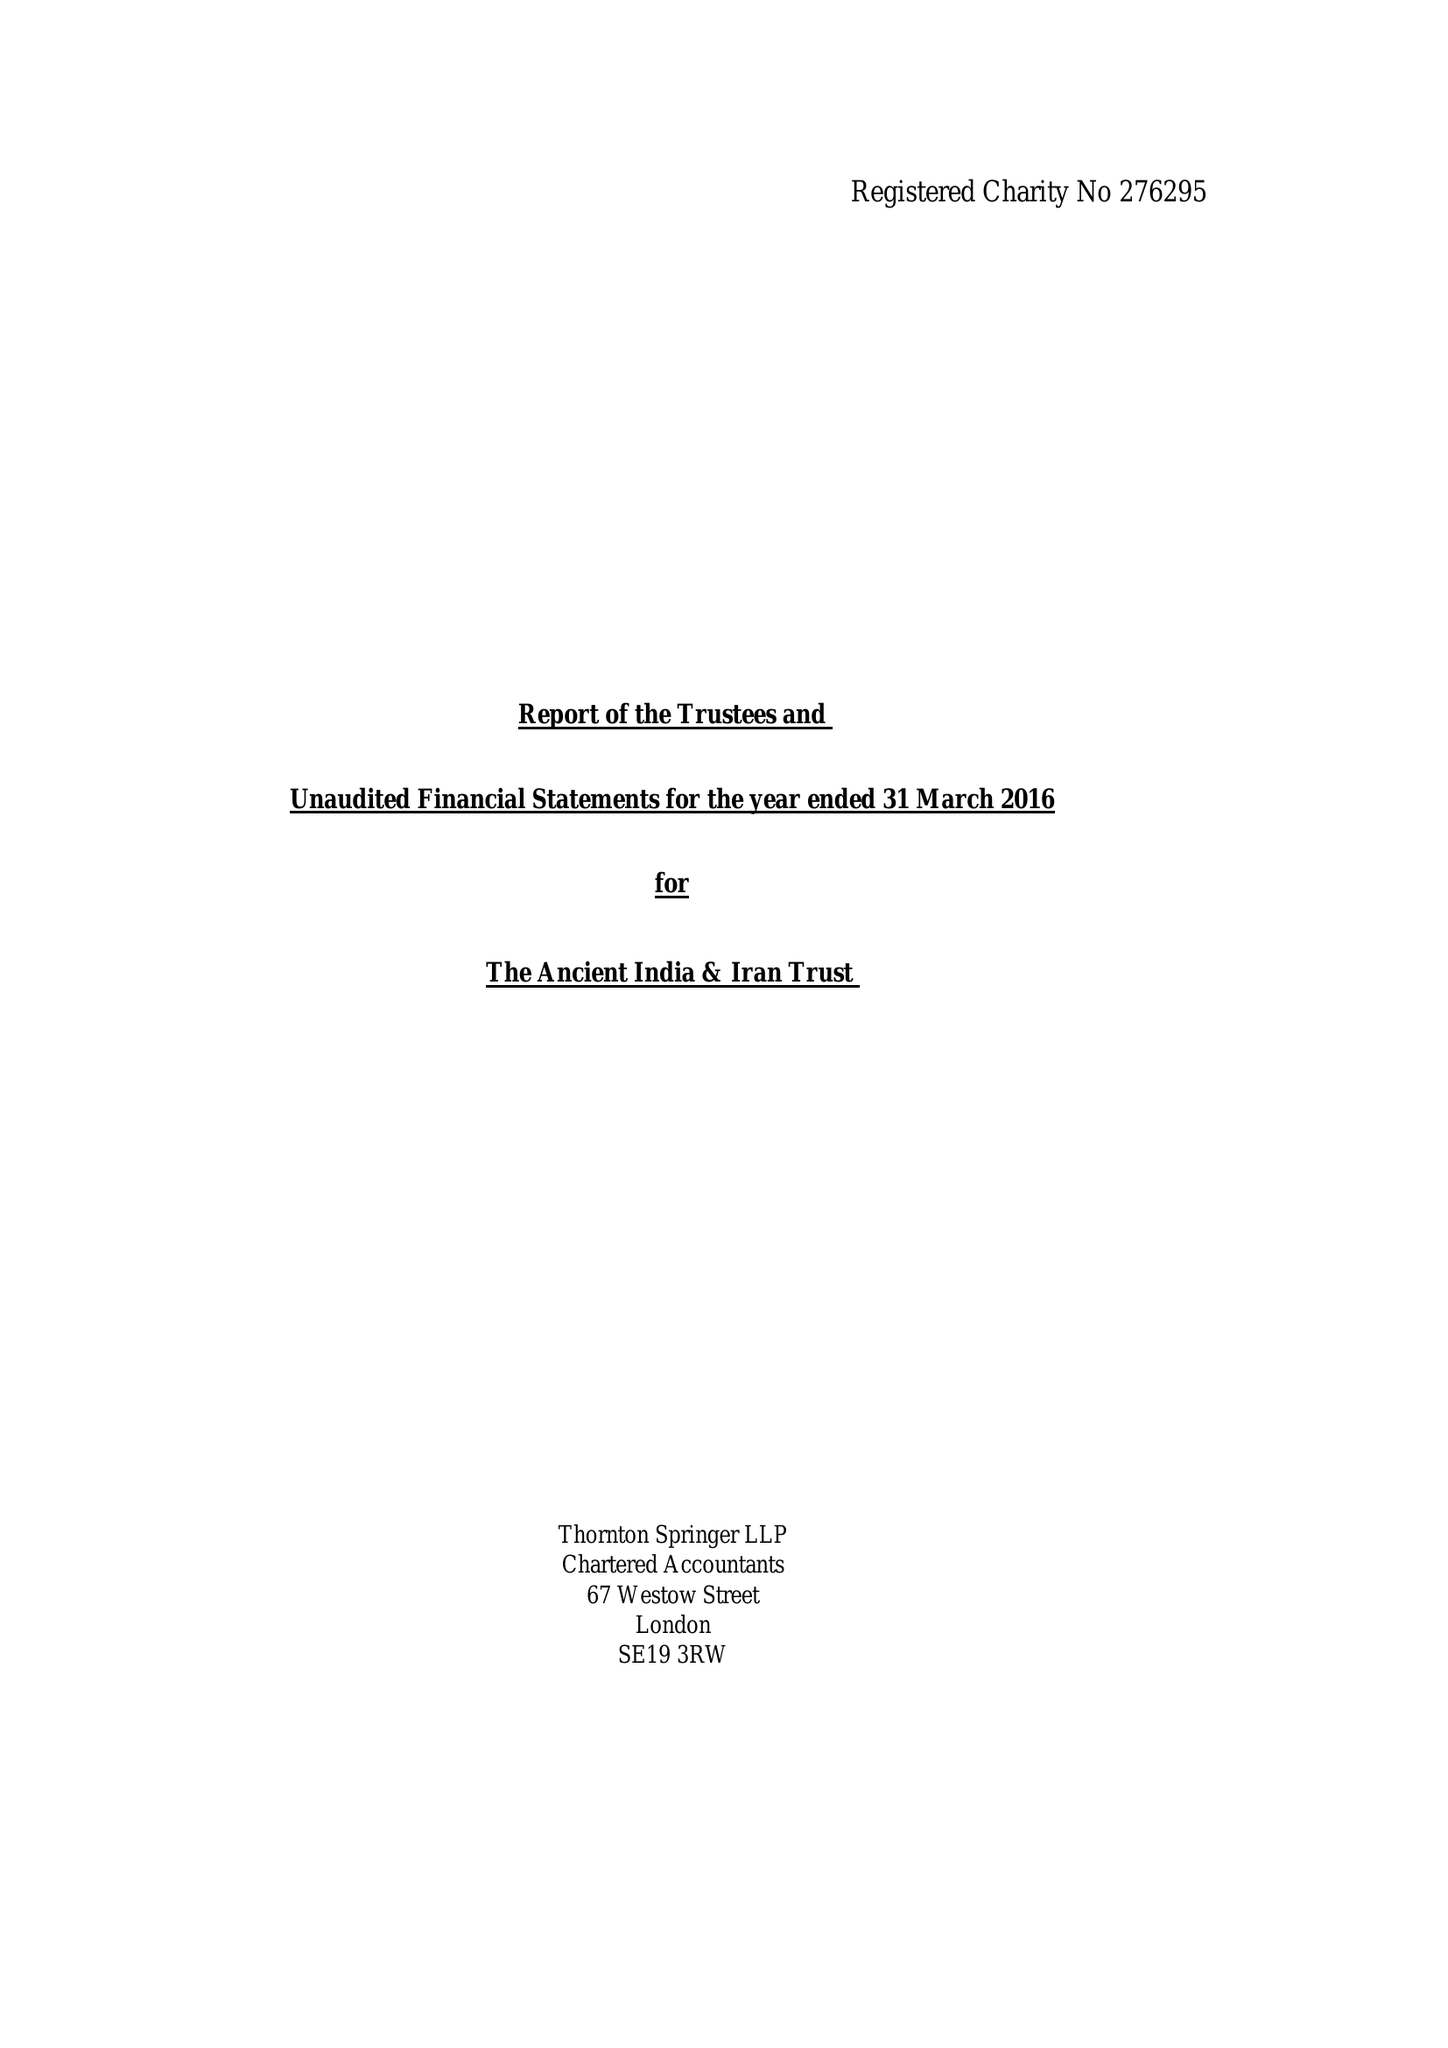What is the value for the address__street_line?
Answer the question using a single word or phrase. 23 BROOKLANDS AVENUE 